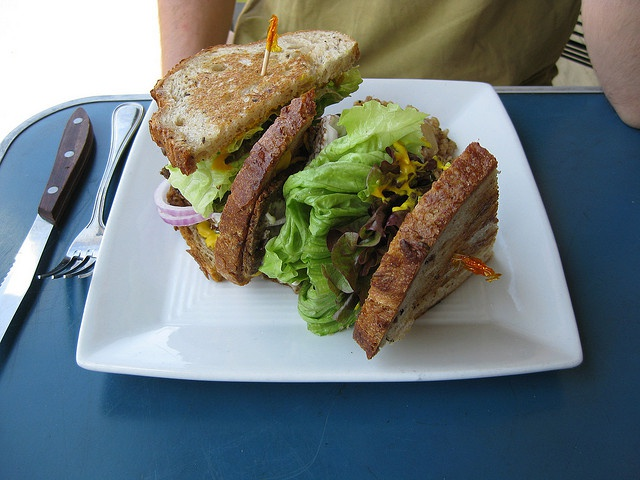Describe the objects in this image and their specific colors. I can see sandwich in white, olive, black, and maroon tones, people in white, olive, gray, and black tones, knife in white, gray, and black tones, and fork in white, lightgray, lightblue, black, and darkgray tones in this image. 